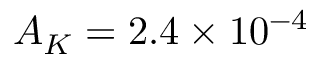Convert formula to latex. <formula><loc_0><loc_0><loc_500><loc_500>A _ { K } = 2 . 4 \times 1 0 ^ { - 4 }</formula> 